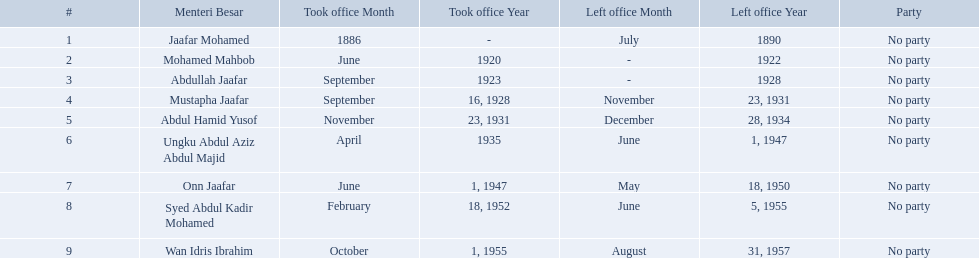Who were the menteri besar of johor? Jaafar Mohamed, Mohamed Mahbob, Abdullah Jaafar, Mustapha Jaafar, Abdul Hamid Yusof, Ungku Abdul Aziz Abdul Majid, Onn Jaafar, Syed Abdul Kadir Mohamed, Wan Idris Ibrahim. Who served the longest? Ungku Abdul Aziz Abdul Majid. What are all the people that were menteri besar of johor? Jaafar Mohamed, Mohamed Mahbob, Abdullah Jaafar, Mustapha Jaafar, Abdul Hamid Yusof, Ungku Abdul Aziz Abdul Majid, Onn Jaafar, Syed Abdul Kadir Mohamed, Wan Idris Ibrahim. Who ruled the longest? Ungku Abdul Aziz Abdul Majid. When did jaafar mohamed take office? 1886. When did mohamed mahbob take office? June 1920. Who was in office no more than 4 years? Mohamed Mahbob. Who were all of the menteri besars? Jaafar Mohamed, Mohamed Mahbob, Abdullah Jaafar, Mustapha Jaafar, Abdul Hamid Yusof, Ungku Abdul Aziz Abdul Majid, Onn Jaafar, Syed Abdul Kadir Mohamed, Wan Idris Ibrahim. When did they take office? 1886, June 1920, September 1923, September 16, 1928, November 23, 1931, April 1935, June 1, 1947, February 18, 1952, October 1, 1955. And when did they leave? July 1890, 1922, 1928, November 23, 1931, December 28, 1934, June 1, 1947, May 18, 1950, June 5, 1955, August 31, 1957. Now, who was in office for less than four years? Mohamed Mahbob. 